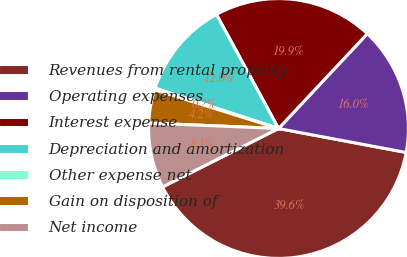Convert chart to OTSL. <chart><loc_0><loc_0><loc_500><loc_500><pie_chart><fcel>Revenues from rental property<fcel>Operating expenses<fcel>Interest expense<fcel>Depreciation and amortization<fcel>Other expense net<fcel>Gain on disposition of<fcel>Net income<nl><fcel>39.61%<fcel>15.97%<fcel>19.91%<fcel>12.03%<fcel>0.21%<fcel>4.15%<fcel>8.09%<nl></chart> 